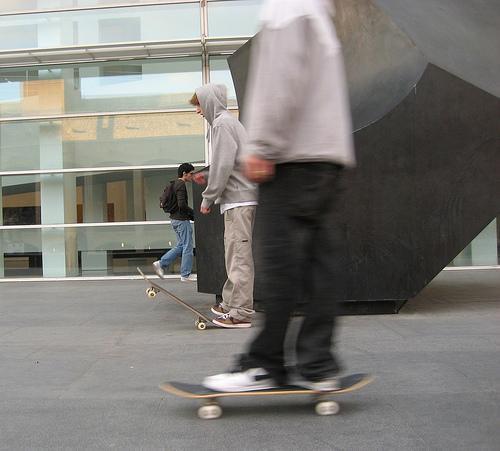How many people are there?
Give a very brief answer. 3. 